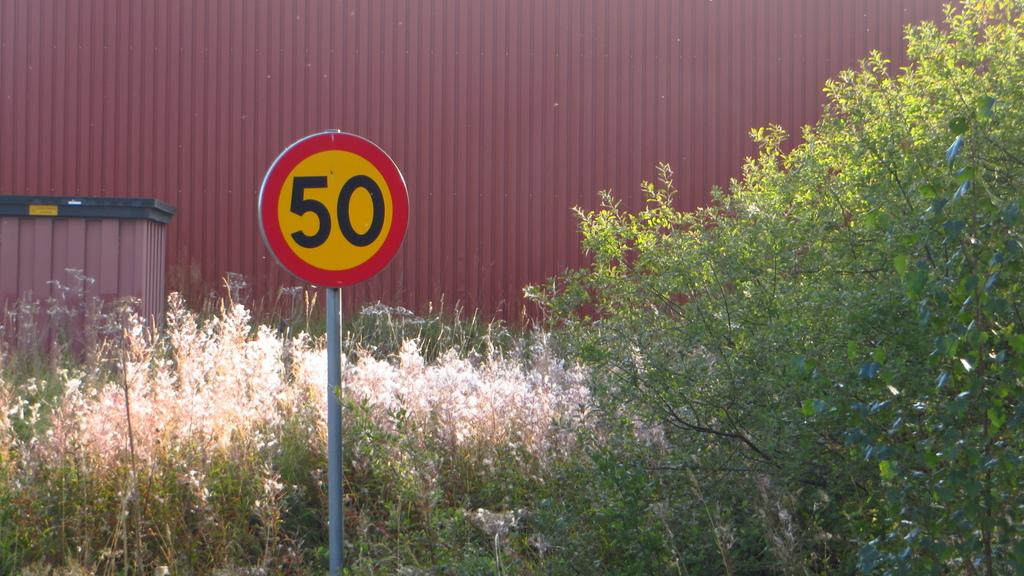<image>
Present a compact description of the photo's key features. A sign with a red border has the number 50 on it. 